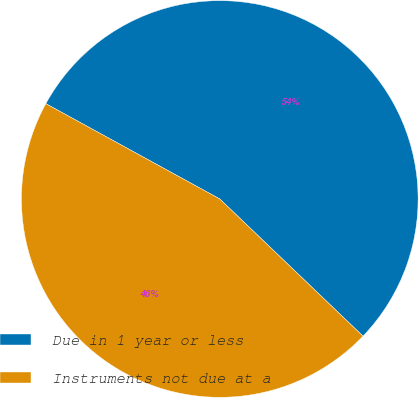Convert chart. <chart><loc_0><loc_0><loc_500><loc_500><pie_chart><fcel>Due in 1 year or less<fcel>Instruments not due at a<nl><fcel>54.18%<fcel>45.82%<nl></chart> 